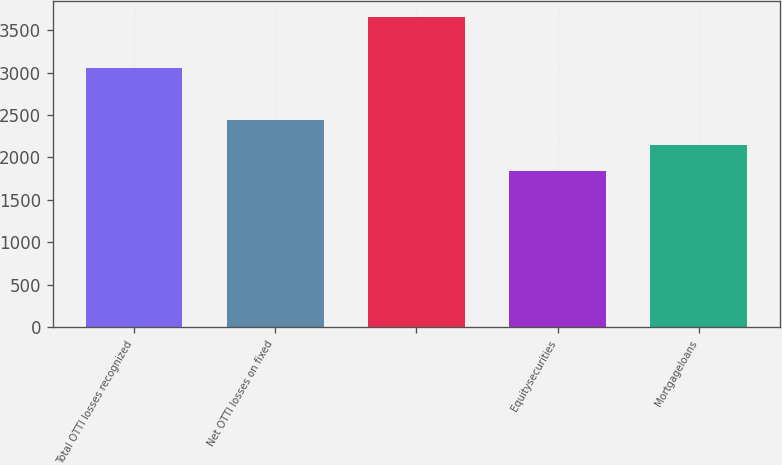Convert chart to OTSL. <chart><loc_0><loc_0><loc_500><loc_500><bar_chart><fcel>Total OTTI losses recognized<fcel>Net OTTI losses on fixed<fcel>Unnamed: 2<fcel>Equitysecurities<fcel>Mortgageloans<nl><fcel>3050<fcel>2445.2<fcel>3654.8<fcel>1840.4<fcel>2142.8<nl></chart> 